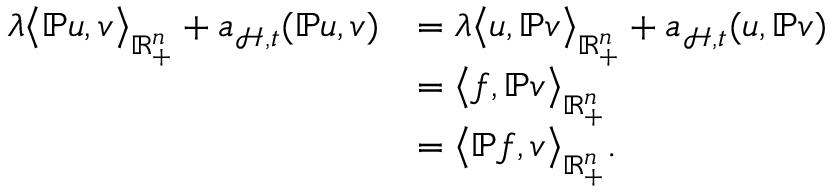<formula> <loc_0><loc_0><loc_500><loc_500>\begin{array} { r l } { \lambda \left \langle \mathbb { P } u , v \right \rangle _ { \mathbb { R } _ { + } ^ { n } } + \mathfrak { a } _ { \mathcal { H } , \mathfrak { t } } ( \mathbb { P } u , v ) } & { = \lambda \left \langle u , \mathbb { P } v \right \rangle _ { \mathbb { R } _ { + } ^ { n } } + \mathfrak { a } _ { \mathcal { H } , \mathfrak { t } } ( u , \mathbb { P } v ) } \\ & { = \left \langle f , \mathbb { P } v \right \rangle _ { \mathbb { R } _ { + } ^ { n } } } \\ & { = \left \langle \mathbb { P } f , v \right \rangle _ { \mathbb { R } _ { + } ^ { n } } . } \end{array}</formula> 